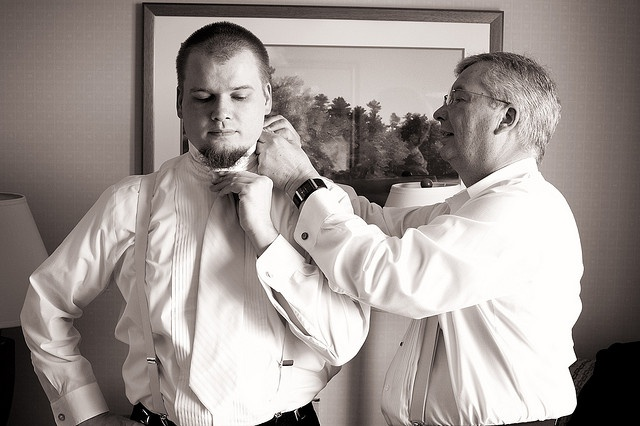Describe the objects in this image and their specific colors. I can see people in gray, white, darkgray, and black tones, people in gray, white, and darkgray tones, and tie in gray, white, and darkgray tones in this image. 